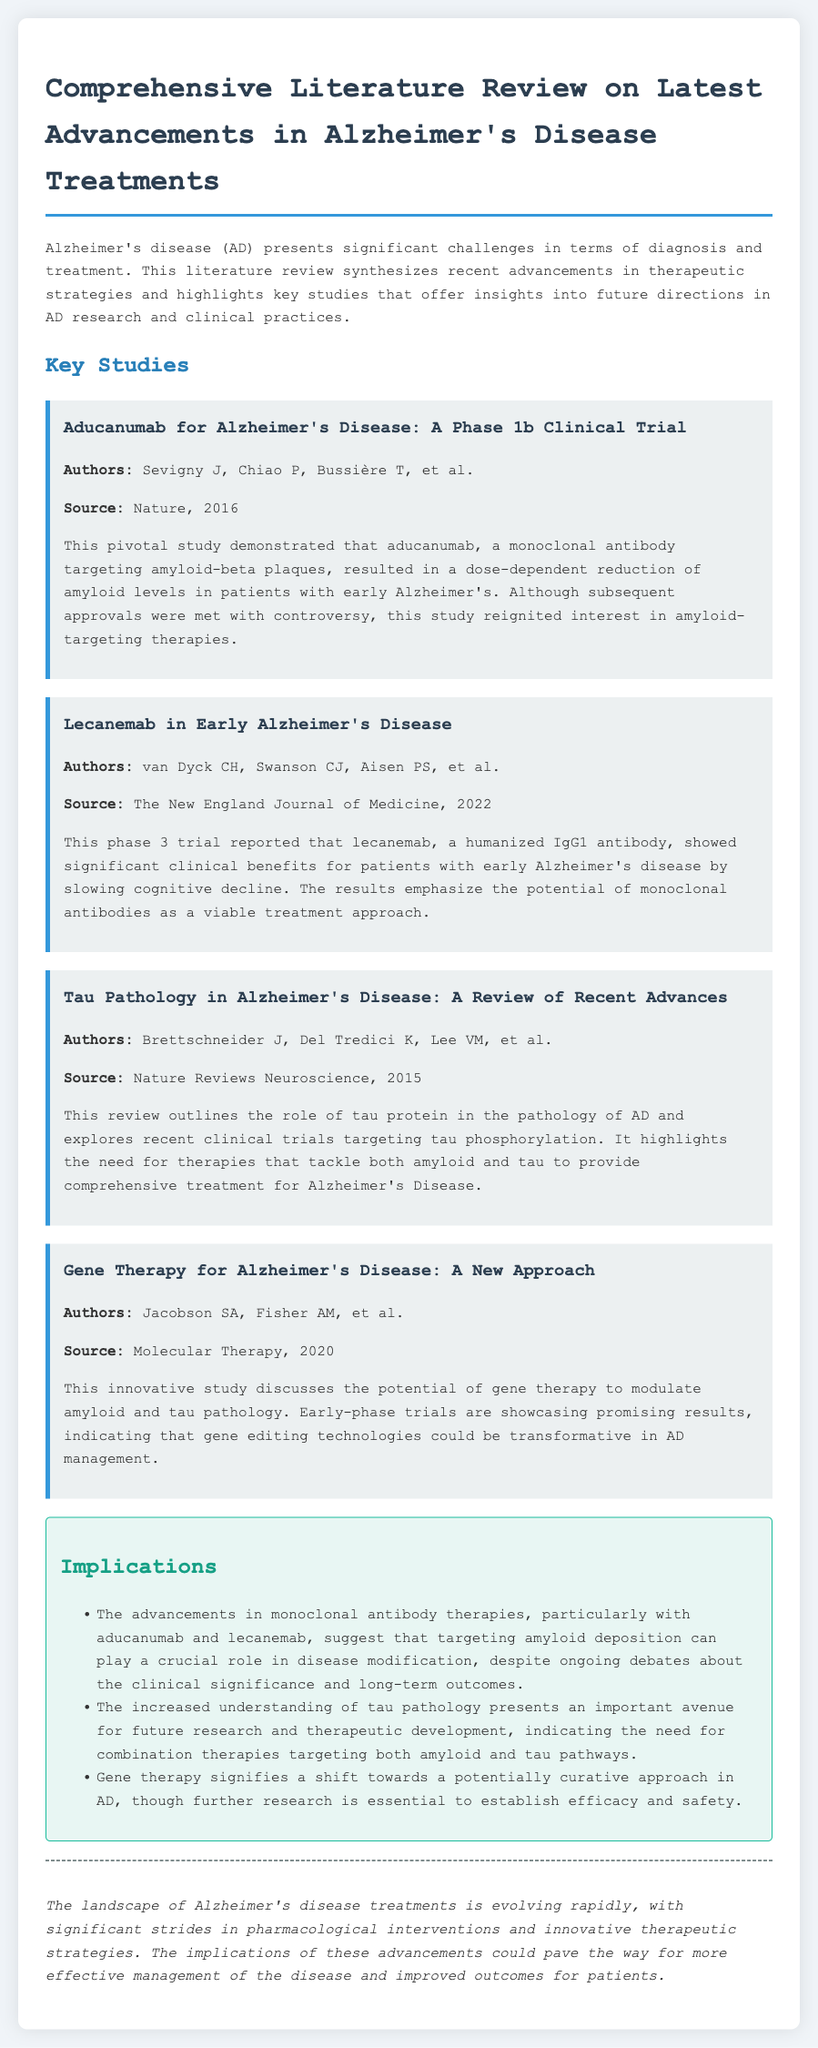What is the main focus of the literature review? The literature review synthesizes recent advancements in therapeutic strategies for Alzheimer's disease.
Answer: Therapeutic strategies Who are the authors of the study on aducanumab? The authors of the aducanumab study are Sevigny J, Chiao P, Bussière T, et al.
Answer: Sevigny J, Chiao P, Bussière T, et al In which journal was the study on lecanemab published? The lecanemab study was published in The New England Journal of Medicine.
Answer: The New England Journal of Medicine What year was the gene therapy study published? The gene therapy study was published in 2020.
Answer: 2020 What is a potential benefit of gene therapy for Alzheimer's disease according to the literature review? Gene therapy could modulate amyloid and tau pathology, showcasing promising results.
Answer: Modulate amyloid and tau pathology What research area does the review highlight as important for future studies? The review highlights the understanding of tau pathology as an important area for future research.
Answer: Tau pathology What type of therapies do aducanumab and lecanemab represent? Both aducanumab and lecanemab represent monoclonal antibody therapies.
Answer: Monoclonal antibody therapies What does the conclusion suggest about the advancements in Alzheimer's treatments? The conclusion suggests that advancements could lead to more effective management and improved outcomes for patients.
Answer: More effective management and improved outcomes 